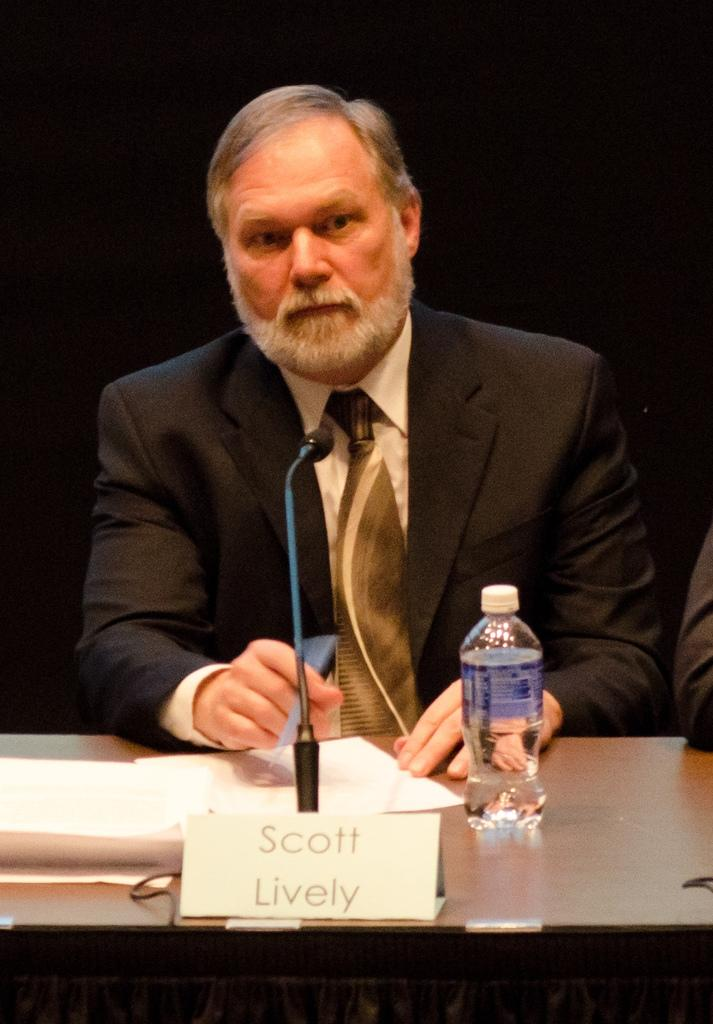What is the man in the image doing? The man is seated on a chair in the image. What objects are in front of the man? There is a water bottle, a paper, a name board, and a microphone on the table in front of the man. What might the man be using the microphone for? The microphone on the table suggests that the man might be giving a speech or presentation. What is the purpose of the name board in front of the man? The name board in front of the man is likely there to identify him or provide information about the event or presentation. Is there a parcel being delivered to the hospital in the image? There is no mention of a parcel or a hospital in the image; it features a man seated on a chair with various objects in front of him. 